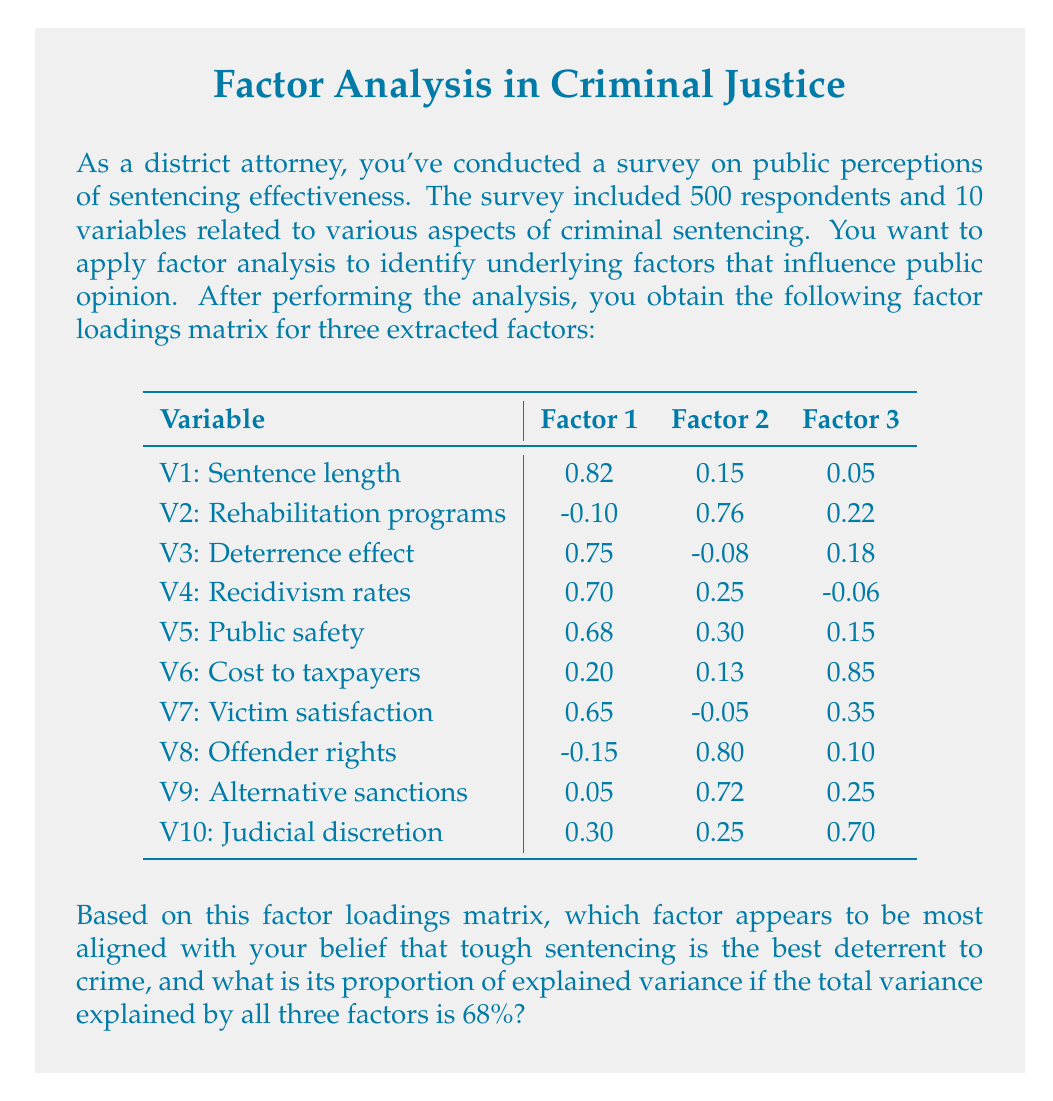What is the answer to this math problem? To answer this question, we need to follow these steps:

1. Identify the factor most aligned with the belief in tough sentencing as a deterrent:
   Factor 1 has high loadings for variables related to tough sentencing and deterrence:
   - V1: Sentence length (0.82)
   - V3: Deterrence effect (0.75)
   - V4: Recidivism rates (0.70)
   - V5: Public safety (0.68)
   - V7: Victim satisfaction (0.65)
   
   This suggests that Factor 1 represents the "Punitive Approach" and is most aligned with the belief.

2. Calculate the proportion of variance explained by Factor 1:
   a. Sum the squared loadings for each factor:
      Factor 1: $0.82^2 + (-0.10)^2 + 0.75^2 + 0.70^2 + 0.68^2 + 0.20^2 + 0.65^2 + (-0.15)^2 + 0.05^2 + 0.30^2 = 2.8954$
      Factor 2: $0.15^2 + 0.76^2 + (-0.08)^2 + 0.25^2 + 0.30^2 + 0.13^2 + (-0.05)^2 + 0.80^2 + 0.72^2 + 0.25^2 = 2.0610$
      Factor 3: $0.05^2 + 0.22^2 + 0.18^2 + (-0.06)^2 + 0.15^2 + 0.85^2 + 0.35^2 + 0.10^2 + 0.25^2 + 0.70^2 = 1.5230$

   b. Calculate the proportion of total variance explained by Factor 1:
      Total variance explained by all factors: $2.8954 + 2.0610 + 1.5230 = 6.4794$
      Proportion explained by Factor 1: $2.8954 / 6.4794 = 0.4468$ or 44.68%

   c. Adjust for the given total explained variance of 68%:
      Final proportion = $0.4468 * 0.68 = 0.3038$ or 30.38%

Therefore, Factor 1 (Punitive Approach) explains 30.38% of the total variance in the data.
Answer: Factor 1 (Punitive Approach), 30.38% of total variance 